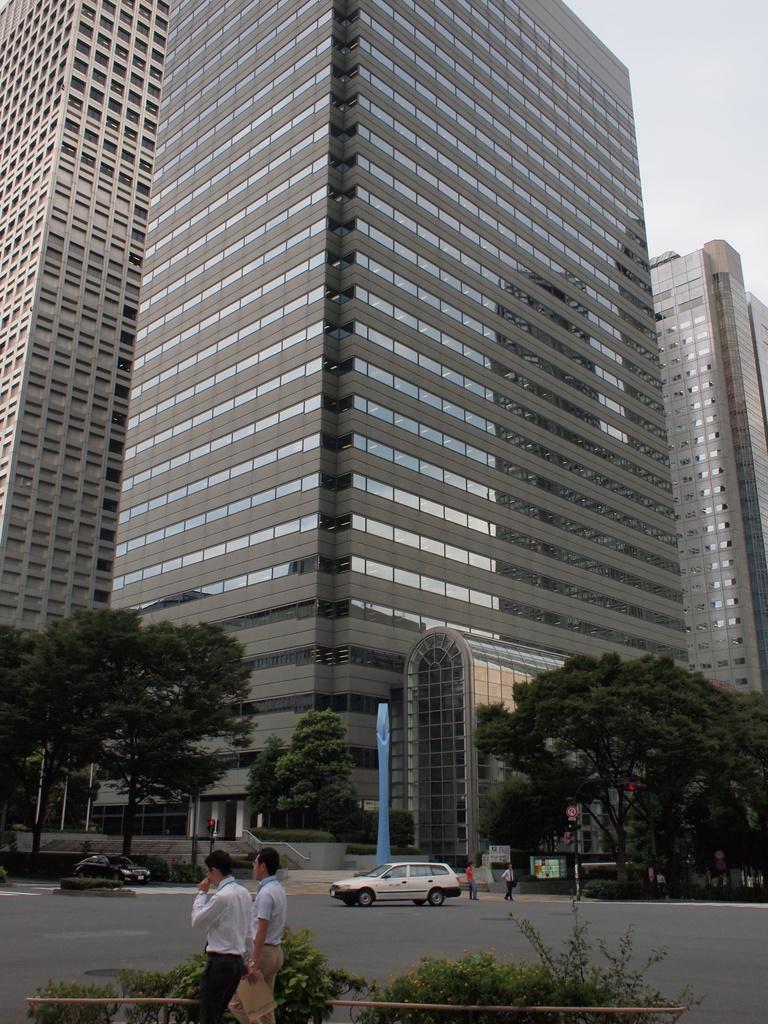How would you summarize this image in a sentence or two? In the image there are two men standing in the front, there are plants behind them followed by cars going on the road, in the back there is a building with trees in front of it and above its sky. 